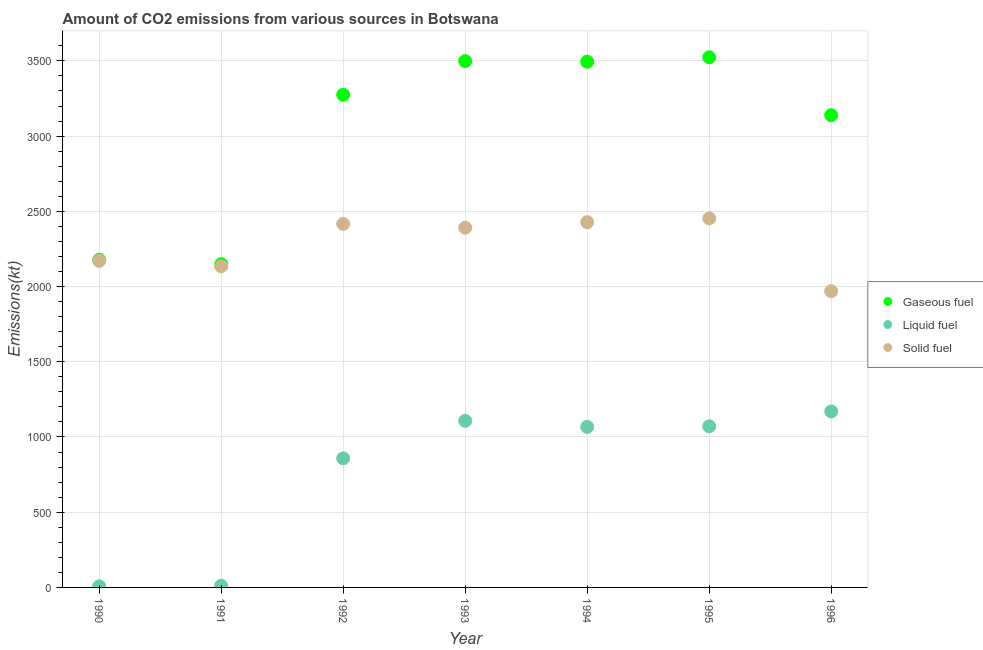What is the amount of co2 emissions from liquid fuel in 1990?
Your answer should be very brief. 7.33. Across all years, what is the maximum amount of co2 emissions from gaseous fuel?
Your response must be concise. 3523.99. Across all years, what is the minimum amount of co2 emissions from liquid fuel?
Give a very brief answer. 7.33. In which year was the amount of co2 emissions from liquid fuel minimum?
Make the answer very short. 1990. What is the total amount of co2 emissions from solid fuel in the graph?
Offer a very short reply. 1.60e+04. What is the difference between the amount of co2 emissions from gaseous fuel in 1990 and that in 1992?
Offer a very short reply. -1096.43. What is the difference between the amount of co2 emissions from gaseous fuel in 1994 and the amount of co2 emissions from liquid fuel in 1996?
Offer a very short reply. 2324.88. What is the average amount of co2 emissions from gaseous fuel per year?
Your answer should be compact. 3036.8. In the year 1991, what is the difference between the amount of co2 emissions from liquid fuel and amount of co2 emissions from solid fuel?
Provide a succinct answer. -2123.19. In how many years, is the amount of co2 emissions from liquid fuel greater than 400 kt?
Make the answer very short. 5. What is the ratio of the amount of co2 emissions from solid fuel in 1990 to that in 1992?
Your response must be concise. 0.9. Is the difference between the amount of co2 emissions from liquid fuel in 1993 and 1995 greater than the difference between the amount of co2 emissions from solid fuel in 1993 and 1995?
Your answer should be very brief. Yes. What is the difference between the highest and the second highest amount of co2 emissions from liquid fuel?
Provide a succinct answer. 62.34. What is the difference between the highest and the lowest amount of co2 emissions from liquid fuel?
Your answer should be compact. 1162.44. In how many years, is the amount of co2 emissions from gaseous fuel greater than the average amount of co2 emissions from gaseous fuel taken over all years?
Your answer should be very brief. 5. Is the sum of the amount of co2 emissions from gaseous fuel in 1991 and 1993 greater than the maximum amount of co2 emissions from liquid fuel across all years?
Offer a terse response. Yes. Does the amount of co2 emissions from gaseous fuel monotonically increase over the years?
Your answer should be compact. No. Is the amount of co2 emissions from liquid fuel strictly greater than the amount of co2 emissions from solid fuel over the years?
Keep it short and to the point. No. What is the difference between two consecutive major ticks on the Y-axis?
Your answer should be very brief. 500. Are the values on the major ticks of Y-axis written in scientific E-notation?
Your answer should be compact. No. Does the graph contain grids?
Your response must be concise. Yes. How are the legend labels stacked?
Make the answer very short. Vertical. What is the title of the graph?
Ensure brevity in your answer.  Amount of CO2 emissions from various sources in Botswana. What is the label or title of the Y-axis?
Ensure brevity in your answer.  Emissions(kt). What is the Emissions(kt) of Gaseous fuel in 1990?
Make the answer very short. 2178.2. What is the Emissions(kt) of Liquid fuel in 1990?
Give a very brief answer. 7.33. What is the Emissions(kt) of Solid fuel in 1990?
Keep it short and to the point. 2170.86. What is the Emissions(kt) in Gaseous fuel in 1991?
Provide a short and direct response. 2148.86. What is the Emissions(kt) of Liquid fuel in 1991?
Provide a short and direct response. 11. What is the Emissions(kt) of Solid fuel in 1991?
Offer a terse response. 2134.19. What is the Emissions(kt) in Gaseous fuel in 1992?
Your response must be concise. 3274.63. What is the Emissions(kt) of Liquid fuel in 1992?
Your answer should be very brief. 858.08. What is the Emissions(kt) of Solid fuel in 1992?
Provide a succinct answer. 2416.55. What is the Emissions(kt) in Gaseous fuel in 1993?
Your answer should be very brief. 3498.32. What is the Emissions(kt) of Liquid fuel in 1993?
Your response must be concise. 1107.43. What is the Emissions(kt) of Solid fuel in 1993?
Your answer should be compact. 2390.88. What is the Emissions(kt) of Gaseous fuel in 1994?
Give a very brief answer. 3494.65. What is the Emissions(kt) in Liquid fuel in 1994?
Your answer should be compact. 1067.1. What is the Emissions(kt) of Solid fuel in 1994?
Provide a short and direct response. 2427.55. What is the Emissions(kt) in Gaseous fuel in 1995?
Offer a very short reply. 3523.99. What is the Emissions(kt) of Liquid fuel in 1995?
Provide a short and direct response. 1070.76. What is the Emissions(kt) of Solid fuel in 1995?
Offer a very short reply. 2453.22. What is the Emissions(kt) in Gaseous fuel in 1996?
Provide a short and direct response. 3138.95. What is the Emissions(kt) of Liquid fuel in 1996?
Ensure brevity in your answer.  1169.77. What is the Emissions(kt) in Solid fuel in 1996?
Provide a short and direct response. 1969.18. Across all years, what is the maximum Emissions(kt) of Gaseous fuel?
Provide a succinct answer. 3523.99. Across all years, what is the maximum Emissions(kt) of Liquid fuel?
Offer a very short reply. 1169.77. Across all years, what is the maximum Emissions(kt) of Solid fuel?
Offer a terse response. 2453.22. Across all years, what is the minimum Emissions(kt) of Gaseous fuel?
Make the answer very short. 2148.86. Across all years, what is the minimum Emissions(kt) of Liquid fuel?
Provide a succinct answer. 7.33. Across all years, what is the minimum Emissions(kt) in Solid fuel?
Keep it short and to the point. 1969.18. What is the total Emissions(kt) in Gaseous fuel in the graph?
Offer a terse response. 2.13e+04. What is the total Emissions(kt) of Liquid fuel in the graph?
Offer a terse response. 5291.48. What is the total Emissions(kt) of Solid fuel in the graph?
Provide a succinct answer. 1.60e+04. What is the difference between the Emissions(kt) of Gaseous fuel in 1990 and that in 1991?
Offer a terse response. 29.34. What is the difference between the Emissions(kt) in Liquid fuel in 1990 and that in 1991?
Offer a terse response. -3.67. What is the difference between the Emissions(kt) in Solid fuel in 1990 and that in 1991?
Keep it short and to the point. 36.67. What is the difference between the Emissions(kt) of Gaseous fuel in 1990 and that in 1992?
Ensure brevity in your answer.  -1096.43. What is the difference between the Emissions(kt) of Liquid fuel in 1990 and that in 1992?
Your answer should be compact. -850.74. What is the difference between the Emissions(kt) of Solid fuel in 1990 and that in 1992?
Your response must be concise. -245.69. What is the difference between the Emissions(kt) in Gaseous fuel in 1990 and that in 1993?
Keep it short and to the point. -1320.12. What is the difference between the Emissions(kt) in Liquid fuel in 1990 and that in 1993?
Ensure brevity in your answer.  -1100.1. What is the difference between the Emissions(kt) of Solid fuel in 1990 and that in 1993?
Your answer should be compact. -220.02. What is the difference between the Emissions(kt) of Gaseous fuel in 1990 and that in 1994?
Give a very brief answer. -1316.45. What is the difference between the Emissions(kt) in Liquid fuel in 1990 and that in 1994?
Your answer should be very brief. -1059.76. What is the difference between the Emissions(kt) of Solid fuel in 1990 and that in 1994?
Offer a very short reply. -256.69. What is the difference between the Emissions(kt) in Gaseous fuel in 1990 and that in 1995?
Provide a succinct answer. -1345.79. What is the difference between the Emissions(kt) in Liquid fuel in 1990 and that in 1995?
Provide a succinct answer. -1063.43. What is the difference between the Emissions(kt) in Solid fuel in 1990 and that in 1995?
Your response must be concise. -282.36. What is the difference between the Emissions(kt) of Gaseous fuel in 1990 and that in 1996?
Provide a succinct answer. -960.75. What is the difference between the Emissions(kt) in Liquid fuel in 1990 and that in 1996?
Keep it short and to the point. -1162.44. What is the difference between the Emissions(kt) in Solid fuel in 1990 and that in 1996?
Your answer should be very brief. 201.69. What is the difference between the Emissions(kt) of Gaseous fuel in 1991 and that in 1992?
Ensure brevity in your answer.  -1125.77. What is the difference between the Emissions(kt) in Liquid fuel in 1991 and that in 1992?
Give a very brief answer. -847.08. What is the difference between the Emissions(kt) in Solid fuel in 1991 and that in 1992?
Give a very brief answer. -282.36. What is the difference between the Emissions(kt) of Gaseous fuel in 1991 and that in 1993?
Keep it short and to the point. -1349.46. What is the difference between the Emissions(kt) of Liquid fuel in 1991 and that in 1993?
Provide a succinct answer. -1096.43. What is the difference between the Emissions(kt) of Solid fuel in 1991 and that in 1993?
Your answer should be compact. -256.69. What is the difference between the Emissions(kt) of Gaseous fuel in 1991 and that in 1994?
Keep it short and to the point. -1345.79. What is the difference between the Emissions(kt) in Liquid fuel in 1991 and that in 1994?
Your response must be concise. -1056.1. What is the difference between the Emissions(kt) in Solid fuel in 1991 and that in 1994?
Your answer should be very brief. -293.36. What is the difference between the Emissions(kt) in Gaseous fuel in 1991 and that in 1995?
Make the answer very short. -1375.12. What is the difference between the Emissions(kt) of Liquid fuel in 1991 and that in 1995?
Your response must be concise. -1059.76. What is the difference between the Emissions(kt) in Solid fuel in 1991 and that in 1995?
Offer a very short reply. -319.03. What is the difference between the Emissions(kt) in Gaseous fuel in 1991 and that in 1996?
Your answer should be compact. -990.09. What is the difference between the Emissions(kt) of Liquid fuel in 1991 and that in 1996?
Give a very brief answer. -1158.77. What is the difference between the Emissions(kt) of Solid fuel in 1991 and that in 1996?
Make the answer very short. 165.01. What is the difference between the Emissions(kt) in Gaseous fuel in 1992 and that in 1993?
Offer a very short reply. -223.69. What is the difference between the Emissions(kt) of Liquid fuel in 1992 and that in 1993?
Keep it short and to the point. -249.36. What is the difference between the Emissions(kt) in Solid fuel in 1992 and that in 1993?
Offer a very short reply. 25.67. What is the difference between the Emissions(kt) in Gaseous fuel in 1992 and that in 1994?
Provide a short and direct response. -220.02. What is the difference between the Emissions(kt) in Liquid fuel in 1992 and that in 1994?
Provide a short and direct response. -209.02. What is the difference between the Emissions(kt) of Solid fuel in 1992 and that in 1994?
Offer a terse response. -11. What is the difference between the Emissions(kt) in Gaseous fuel in 1992 and that in 1995?
Your answer should be compact. -249.36. What is the difference between the Emissions(kt) of Liquid fuel in 1992 and that in 1995?
Provide a short and direct response. -212.69. What is the difference between the Emissions(kt) of Solid fuel in 1992 and that in 1995?
Offer a terse response. -36.67. What is the difference between the Emissions(kt) of Gaseous fuel in 1992 and that in 1996?
Make the answer very short. 135.68. What is the difference between the Emissions(kt) in Liquid fuel in 1992 and that in 1996?
Ensure brevity in your answer.  -311.69. What is the difference between the Emissions(kt) in Solid fuel in 1992 and that in 1996?
Provide a short and direct response. 447.37. What is the difference between the Emissions(kt) in Gaseous fuel in 1993 and that in 1994?
Your answer should be very brief. 3.67. What is the difference between the Emissions(kt) of Liquid fuel in 1993 and that in 1994?
Your response must be concise. 40.34. What is the difference between the Emissions(kt) of Solid fuel in 1993 and that in 1994?
Offer a terse response. -36.67. What is the difference between the Emissions(kt) of Gaseous fuel in 1993 and that in 1995?
Your answer should be compact. -25.67. What is the difference between the Emissions(kt) of Liquid fuel in 1993 and that in 1995?
Your answer should be very brief. 36.67. What is the difference between the Emissions(kt) in Solid fuel in 1993 and that in 1995?
Keep it short and to the point. -62.34. What is the difference between the Emissions(kt) of Gaseous fuel in 1993 and that in 1996?
Offer a terse response. 359.37. What is the difference between the Emissions(kt) in Liquid fuel in 1993 and that in 1996?
Provide a succinct answer. -62.34. What is the difference between the Emissions(kt) in Solid fuel in 1993 and that in 1996?
Give a very brief answer. 421.7. What is the difference between the Emissions(kt) in Gaseous fuel in 1994 and that in 1995?
Your response must be concise. -29.34. What is the difference between the Emissions(kt) of Liquid fuel in 1994 and that in 1995?
Your answer should be very brief. -3.67. What is the difference between the Emissions(kt) in Solid fuel in 1994 and that in 1995?
Offer a very short reply. -25.67. What is the difference between the Emissions(kt) of Gaseous fuel in 1994 and that in 1996?
Offer a very short reply. 355.7. What is the difference between the Emissions(kt) in Liquid fuel in 1994 and that in 1996?
Provide a short and direct response. -102.68. What is the difference between the Emissions(kt) in Solid fuel in 1994 and that in 1996?
Give a very brief answer. 458.38. What is the difference between the Emissions(kt) in Gaseous fuel in 1995 and that in 1996?
Your response must be concise. 385.04. What is the difference between the Emissions(kt) of Liquid fuel in 1995 and that in 1996?
Give a very brief answer. -99.01. What is the difference between the Emissions(kt) in Solid fuel in 1995 and that in 1996?
Offer a very short reply. 484.04. What is the difference between the Emissions(kt) in Gaseous fuel in 1990 and the Emissions(kt) in Liquid fuel in 1991?
Provide a succinct answer. 2167.2. What is the difference between the Emissions(kt) of Gaseous fuel in 1990 and the Emissions(kt) of Solid fuel in 1991?
Your answer should be very brief. 44. What is the difference between the Emissions(kt) of Liquid fuel in 1990 and the Emissions(kt) of Solid fuel in 1991?
Your answer should be compact. -2126.86. What is the difference between the Emissions(kt) of Gaseous fuel in 1990 and the Emissions(kt) of Liquid fuel in 1992?
Keep it short and to the point. 1320.12. What is the difference between the Emissions(kt) of Gaseous fuel in 1990 and the Emissions(kt) of Solid fuel in 1992?
Provide a short and direct response. -238.35. What is the difference between the Emissions(kt) in Liquid fuel in 1990 and the Emissions(kt) in Solid fuel in 1992?
Offer a terse response. -2409.22. What is the difference between the Emissions(kt) of Gaseous fuel in 1990 and the Emissions(kt) of Liquid fuel in 1993?
Offer a terse response. 1070.76. What is the difference between the Emissions(kt) of Gaseous fuel in 1990 and the Emissions(kt) of Solid fuel in 1993?
Make the answer very short. -212.69. What is the difference between the Emissions(kt) in Liquid fuel in 1990 and the Emissions(kt) in Solid fuel in 1993?
Make the answer very short. -2383.55. What is the difference between the Emissions(kt) of Gaseous fuel in 1990 and the Emissions(kt) of Liquid fuel in 1994?
Keep it short and to the point. 1111.1. What is the difference between the Emissions(kt) of Gaseous fuel in 1990 and the Emissions(kt) of Solid fuel in 1994?
Your response must be concise. -249.36. What is the difference between the Emissions(kt) in Liquid fuel in 1990 and the Emissions(kt) in Solid fuel in 1994?
Your answer should be very brief. -2420.22. What is the difference between the Emissions(kt) of Gaseous fuel in 1990 and the Emissions(kt) of Liquid fuel in 1995?
Give a very brief answer. 1107.43. What is the difference between the Emissions(kt) of Gaseous fuel in 1990 and the Emissions(kt) of Solid fuel in 1995?
Offer a terse response. -275.02. What is the difference between the Emissions(kt) in Liquid fuel in 1990 and the Emissions(kt) in Solid fuel in 1995?
Give a very brief answer. -2445.89. What is the difference between the Emissions(kt) in Gaseous fuel in 1990 and the Emissions(kt) in Liquid fuel in 1996?
Your answer should be compact. 1008.42. What is the difference between the Emissions(kt) in Gaseous fuel in 1990 and the Emissions(kt) in Solid fuel in 1996?
Give a very brief answer. 209.02. What is the difference between the Emissions(kt) of Liquid fuel in 1990 and the Emissions(kt) of Solid fuel in 1996?
Keep it short and to the point. -1961.85. What is the difference between the Emissions(kt) of Gaseous fuel in 1991 and the Emissions(kt) of Liquid fuel in 1992?
Provide a succinct answer. 1290.78. What is the difference between the Emissions(kt) in Gaseous fuel in 1991 and the Emissions(kt) in Solid fuel in 1992?
Your answer should be compact. -267.69. What is the difference between the Emissions(kt) of Liquid fuel in 1991 and the Emissions(kt) of Solid fuel in 1992?
Give a very brief answer. -2405.55. What is the difference between the Emissions(kt) in Gaseous fuel in 1991 and the Emissions(kt) in Liquid fuel in 1993?
Offer a terse response. 1041.43. What is the difference between the Emissions(kt) in Gaseous fuel in 1991 and the Emissions(kt) in Solid fuel in 1993?
Your response must be concise. -242.02. What is the difference between the Emissions(kt) in Liquid fuel in 1991 and the Emissions(kt) in Solid fuel in 1993?
Keep it short and to the point. -2379.88. What is the difference between the Emissions(kt) in Gaseous fuel in 1991 and the Emissions(kt) in Liquid fuel in 1994?
Your answer should be very brief. 1081.77. What is the difference between the Emissions(kt) in Gaseous fuel in 1991 and the Emissions(kt) in Solid fuel in 1994?
Ensure brevity in your answer.  -278.69. What is the difference between the Emissions(kt) in Liquid fuel in 1991 and the Emissions(kt) in Solid fuel in 1994?
Make the answer very short. -2416.55. What is the difference between the Emissions(kt) of Gaseous fuel in 1991 and the Emissions(kt) of Liquid fuel in 1995?
Your answer should be very brief. 1078.1. What is the difference between the Emissions(kt) in Gaseous fuel in 1991 and the Emissions(kt) in Solid fuel in 1995?
Offer a terse response. -304.36. What is the difference between the Emissions(kt) of Liquid fuel in 1991 and the Emissions(kt) of Solid fuel in 1995?
Offer a terse response. -2442.22. What is the difference between the Emissions(kt) of Gaseous fuel in 1991 and the Emissions(kt) of Liquid fuel in 1996?
Keep it short and to the point. 979.09. What is the difference between the Emissions(kt) of Gaseous fuel in 1991 and the Emissions(kt) of Solid fuel in 1996?
Provide a succinct answer. 179.68. What is the difference between the Emissions(kt) in Liquid fuel in 1991 and the Emissions(kt) in Solid fuel in 1996?
Your answer should be compact. -1958.18. What is the difference between the Emissions(kt) in Gaseous fuel in 1992 and the Emissions(kt) in Liquid fuel in 1993?
Provide a short and direct response. 2167.2. What is the difference between the Emissions(kt) in Gaseous fuel in 1992 and the Emissions(kt) in Solid fuel in 1993?
Your response must be concise. 883.75. What is the difference between the Emissions(kt) in Liquid fuel in 1992 and the Emissions(kt) in Solid fuel in 1993?
Ensure brevity in your answer.  -1532.81. What is the difference between the Emissions(kt) in Gaseous fuel in 1992 and the Emissions(kt) in Liquid fuel in 1994?
Provide a short and direct response. 2207.53. What is the difference between the Emissions(kt) in Gaseous fuel in 1992 and the Emissions(kt) in Solid fuel in 1994?
Ensure brevity in your answer.  847.08. What is the difference between the Emissions(kt) of Liquid fuel in 1992 and the Emissions(kt) of Solid fuel in 1994?
Provide a succinct answer. -1569.48. What is the difference between the Emissions(kt) in Gaseous fuel in 1992 and the Emissions(kt) in Liquid fuel in 1995?
Offer a very short reply. 2203.87. What is the difference between the Emissions(kt) in Gaseous fuel in 1992 and the Emissions(kt) in Solid fuel in 1995?
Provide a succinct answer. 821.41. What is the difference between the Emissions(kt) in Liquid fuel in 1992 and the Emissions(kt) in Solid fuel in 1995?
Your answer should be compact. -1595.14. What is the difference between the Emissions(kt) in Gaseous fuel in 1992 and the Emissions(kt) in Liquid fuel in 1996?
Ensure brevity in your answer.  2104.86. What is the difference between the Emissions(kt) of Gaseous fuel in 1992 and the Emissions(kt) of Solid fuel in 1996?
Your answer should be very brief. 1305.45. What is the difference between the Emissions(kt) of Liquid fuel in 1992 and the Emissions(kt) of Solid fuel in 1996?
Provide a succinct answer. -1111.1. What is the difference between the Emissions(kt) of Gaseous fuel in 1993 and the Emissions(kt) of Liquid fuel in 1994?
Provide a short and direct response. 2431.22. What is the difference between the Emissions(kt) in Gaseous fuel in 1993 and the Emissions(kt) in Solid fuel in 1994?
Give a very brief answer. 1070.76. What is the difference between the Emissions(kt) of Liquid fuel in 1993 and the Emissions(kt) of Solid fuel in 1994?
Make the answer very short. -1320.12. What is the difference between the Emissions(kt) of Gaseous fuel in 1993 and the Emissions(kt) of Liquid fuel in 1995?
Provide a succinct answer. 2427.55. What is the difference between the Emissions(kt) in Gaseous fuel in 1993 and the Emissions(kt) in Solid fuel in 1995?
Keep it short and to the point. 1045.1. What is the difference between the Emissions(kt) in Liquid fuel in 1993 and the Emissions(kt) in Solid fuel in 1995?
Make the answer very short. -1345.79. What is the difference between the Emissions(kt) in Gaseous fuel in 1993 and the Emissions(kt) in Liquid fuel in 1996?
Ensure brevity in your answer.  2328.55. What is the difference between the Emissions(kt) of Gaseous fuel in 1993 and the Emissions(kt) of Solid fuel in 1996?
Offer a terse response. 1529.14. What is the difference between the Emissions(kt) in Liquid fuel in 1993 and the Emissions(kt) in Solid fuel in 1996?
Offer a terse response. -861.75. What is the difference between the Emissions(kt) in Gaseous fuel in 1994 and the Emissions(kt) in Liquid fuel in 1995?
Make the answer very short. 2423.89. What is the difference between the Emissions(kt) of Gaseous fuel in 1994 and the Emissions(kt) of Solid fuel in 1995?
Your response must be concise. 1041.43. What is the difference between the Emissions(kt) in Liquid fuel in 1994 and the Emissions(kt) in Solid fuel in 1995?
Give a very brief answer. -1386.13. What is the difference between the Emissions(kt) in Gaseous fuel in 1994 and the Emissions(kt) in Liquid fuel in 1996?
Provide a short and direct response. 2324.88. What is the difference between the Emissions(kt) in Gaseous fuel in 1994 and the Emissions(kt) in Solid fuel in 1996?
Keep it short and to the point. 1525.47. What is the difference between the Emissions(kt) of Liquid fuel in 1994 and the Emissions(kt) of Solid fuel in 1996?
Offer a very short reply. -902.08. What is the difference between the Emissions(kt) of Gaseous fuel in 1995 and the Emissions(kt) of Liquid fuel in 1996?
Provide a short and direct response. 2354.21. What is the difference between the Emissions(kt) in Gaseous fuel in 1995 and the Emissions(kt) in Solid fuel in 1996?
Keep it short and to the point. 1554.81. What is the difference between the Emissions(kt) in Liquid fuel in 1995 and the Emissions(kt) in Solid fuel in 1996?
Your response must be concise. -898.41. What is the average Emissions(kt) in Gaseous fuel per year?
Offer a terse response. 3036.8. What is the average Emissions(kt) of Liquid fuel per year?
Give a very brief answer. 755.93. What is the average Emissions(kt) in Solid fuel per year?
Your response must be concise. 2280.35. In the year 1990, what is the difference between the Emissions(kt) of Gaseous fuel and Emissions(kt) of Liquid fuel?
Your answer should be very brief. 2170.86. In the year 1990, what is the difference between the Emissions(kt) of Gaseous fuel and Emissions(kt) of Solid fuel?
Offer a terse response. 7.33. In the year 1990, what is the difference between the Emissions(kt) of Liquid fuel and Emissions(kt) of Solid fuel?
Your answer should be very brief. -2163.53. In the year 1991, what is the difference between the Emissions(kt) of Gaseous fuel and Emissions(kt) of Liquid fuel?
Offer a very short reply. 2137.86. In the year 1991, what is the difference between the Emissions(kt) of Gaseous fuel and Emissions(kt) of Solid fuel?
Keep it short and to the point. 14.67. In the year 1991, what is the difference between the Emissions(kt) in Liquid fuel and Emissions(kt) in Solid fuel?
Provide a short and direct response. -2123.19. In the year 1992, what is the difference between the Emissions(kt) in Gaseous fuel and Emissions(kt) in Liquid fuel?
Give a very brief answer. 2416.55. In the year 1992, what is the difference between the Emissions(kt) of Gaseous fuel and Emissions(kt) of Solid fuel?
Provide a succinct answer. 858.08. In the year 1992, what is the difference between the Emissions(kt) of Liquid fuel and Emissions(kt) of Solid fuel?
Offer a very short reply. -1558.47. In the year 1993, what is the difference between the Emissions(kt) of Gaseous fuel and Emissions(kt) of Liquid fuel?
Provide a succinct answer. 2390.88. In the year 1993, what is the difference between the Emissions(kt) in Gaseous fuel and Emissions(kt) in Solid fuel?
Provide a succinct answer. 1107.43. In the year 1993, what is the difference between the Emissions(kt) in Liquid fuel and Emissions(kt) in Solid fuel?
Offer a terse response. -1283.45. In the year 1994, what is the difference between the Emissions(kt) of Gaseous fuel and Emissions(kt) of Liquid fuel?
Your answer should be very brief. 2427.55. In the year 1994, what is the difference between the Emissions(kt) of Gaseous fuel and Emissions(kt) of Solid fuel?
Your answer should be compact. 1067.1. In the year 1994, what is the difference between the Emissions(kt) in Liquid fuel and Emissions(kt) in Solid fuel?
Make the answer very short. -1360.46. In the year 1995, what is the difference between the Emissions(kt) in Gaseous fuel and Emissions(kt) in Liquid fuel?
Your answer should be compact. 2453.22. In the year 1995, what is the difference between the Emissions(kt) in Gaseous fuel and Emissions(kt) in Solid fuel?
Offer a terse response. 1070.76. In the year 1995, what is the difference between the Emissions(kt) of Liquid fuel and Emissions(kt) of Solid fuel?
Provide a short and direct response. -1382.46. In the year 1996, what is the difference between the Emissions(kt) in Gaseous fuel and Emissions(kt) in Liquid fuel?
Offer a terse response. 1969.18. In the year 1996, what is the difference between the Emissions(kt) of Gaseous fuel and Emissions(kt) of Solid fuel?
Your response must be concise. 1169.77. In the year 1996, what is the difference between the Emissions(kt) of Liquid fuel and Emissions(kt) of Solid fuel?
Give a very brief answer. -799.41. What is the ratio of the Emissions(kt) of Gaseous fuel in 1990 to that in 1991?
Ensure brevity in your answer.  1.01. What is the ratio of the Emissions(kt) of Liquid fuel in 1990 to that in 1991?
Your response must be concise. 0.67. What is the ratio of the Emissions(kt) in Solid fuel in 1990 to that in 1991?
Provide a short and direct response. 1.02. What is the ratio of the Emissions(kt) of Gaseous fuel in 1990 to that in 1992?
Your answer should be very brief. 0.67. What is the ratio of the Emissions(kt) in Liquid fuel in 1990 to that in 1992?
Provide a short and direct response. 0.01. What is the ratio of the Emissions(kt) in Solid fuel in 1990 to that in 1992?
Your answer should be compact. 0.9. What is the ratio of the Emissions(kt) of Gaseous fuel in 1990 to that in 1993?
Offer a terse response. 0.62. What is the ratio of the Emissions(kt) in Liquid fuel in 1990 to that in 1993?
Ensure brevity in your answer.  0.01. What is the ratio of the Emissions(kt) of Solid fuel in 1990 to that in 1993?
Provide a succinct answer. 0.91. What is the ratio of the Emissions(kt) of Gaseous fuel in 1990 to that in 1994?
Your response must be concise. 0.62. What is the ratio of the Emissions(kt) in Liquid fuel in 1990 to that in 1994?
Provide a short and direct response. 0.01. What is the ratio of the Emissions(kt) in Solid fuel in 1990 to that in 1994?
Your answer should be very brief. 0.89. What is the ratio of the Emissions(kt) in Gaseous fuel in 1990 to that in 1995?
Make the answer very short. 0.62. What is the ratio of the Emissions(kt) in Liquid fuel in 1990 to that in 1995?
Keep it short and to the point. 0.01. What is the ratio of the Emissions(kt) of Solid fuel in 1990 to that in 1995?
Offer a terse response. 0.88. What is the ratio of the Emissions(kt) of Gaseous fuel in 1990 to that in 1996?
Give a very brief answer. 0.69. What is the ratio of the Emissions(kt) in Liquid fuel in 1990 to that in 1996?
Your answer should be compact. 0.01. What is the ratio of the Emissions(kt) in Solid fuel in 1990 to that in 1996?
Give a very brief answer. 1.1. What is the ratio of the Emissions(kt) in Gaseous fuel in 1991 to that in 1992?
Ensure brevity in your answer.  0.66. What is the ratio of the Emissions(kt) in Liquid fuel in 1991 to that in 1992?
Ensure brevity in your answer.  0.01. What is the ratio of the Emissions(kt) of Solid fuel in 1991 to that in 1992?
Give a very brief answer. 0.88. What is the ratio of the Emissions(kt) of Gaseous fuel in 1991 to that in 1993?
Offer a terse response. 0.61. What is the ratio of the Emissions(kt) in Liquid fuel in 1991 to that in 1993?
Offer a very short reply. 0.01. What is the ratio of the Emissions(kt) in Solid fuel in 1991 to that in 1993?
Make the answer very short. 0.89. What is the ratio of the Emissions(kt) of Gaseous fuel in 1991 to that in 1994?
Give a very brief answer. 0.61. What is the ratio of the Emissions(kt) of Liquid fuel in 1991 to that in 1994?
Offer a very short reply. 0.01. What is the ratio of the Emissions(kt) in Solid fuel in 1991 to that in 1994?
Provide a succinct answer. 0.88. What is the ratio of the Emissions(kt) of Gaseous fuel in 1991 to that in 1995?
Your response must be concise. 0.61. What is the ratio of the Emissions(kt) in Liquid fuel in 1991 to that in 1995?
Keep it short and to the point. 0.01. What is the ratio of the Emissions(kt) in Solid fuel in 1991 to that in 1995?
Give a very brief answer. 0.87. What is the ratio of the Emissions(kt) of Gaseous fuel in 1991 to that in 1996?
Ensure brevity in your answer.  0.68. What is the ratio of the Emissions(kt) in Liquid fuel in 1991 to that in 1996?
Offer a terse response. 0.01. What is the ratio of the Emissions(kt) in Solid fuel in 1991 to that in 1996?
Offer a very short reply. 1.08. What is the ratio of the Emissions(kt) of Gaseous fuel in 1992 to that in 1993?
Your answer should be compact. 0.94. What is the ratio of the Emissions(kt) in Liquid fuel in 1992 to that in 1993?
Provide a short and direct response. 0.77. What is the ratio of the Emissions(kt) of Solid fuel in 1992 to that in 1993?
Make the answer very short. 1.01. What is the ratio of the Emissions(kt) of Gaseous fuel in 1992 to that in 1994?
Your answer should be very brief. 0.94. What is the ratio of the Emissions(kt) in Liquid fuel in 1992 to that in 1994?
Give a very brief answer. 0.8. What is the ratio of the Emissions(kt) of Solid fuel in 1992 to that in 1994?
Offer a terse response. 1. What is the ratio of the Emissions(kt) of Gaseous fuel in 1992 to that in 1995?
Offer a terse response. 0.93. What is the ratio of the Emissions(kt) of Liquid fuel in 1992 to that in 1995?
Offer a terse response. 0.8. What is the ratio of the Emissions(kt) of Solid fuel in 1992 to that in 1995?
Give a very brief answer. 0.99. What is the ratio of the Emissions(kt) in Gaseous fuel in 1992 to that in 1996?
Your answer should be compact. 1.04. What is the ratio of the Emissions(kt) in Liquid fuel in 1992 to that in 1996?
Make the answer very short. 0.73. What is the ratio of the Emissions(kt) in Solid fuel in 1992 to that in 1996?
Your answer should be compact. 1.23. What is the ratio of the Emissions(kt) in Liquid fuel in 1993 to that in 1994?
Provide a short and direct response. 1.04. What is the ratio of the Emissions(kt) of Solid fuel in 1993 to that in 1994?
Provide a succinct answer. 0.98. What is the ratio of the Emissions(kt) of Liquid fuel in 1993 to that in 1995?
Offer a very short reply. 1.03. What is the ratio of the Emissions(kt) in Solid fuel in 1993 to that in 1995?
Keep it short and to the point. 0.97. What is the ratio of the Emissions(kt) of Gaseous fuel in 1993 to that in 1996?
Offer a very short reply. 1.11. What is the ratio of the Emissions(kt) of Liquid fuel in 1993 to that in 1996?
Offer a terse response. 0.95. What is the ratio of the Emissions(kt) of Solid fuel in 1993 to that in 1996?
Offer a terse response. 1.21. What is the ratio of the Emissions(kt) of Liquid fuel in 1994 to that in 1995?
Your answer should be compact. 1. What is the ratio of the Emissions(kt) in Gaseous fuel in 1994 to that in 1996?
Give a very brief answer. 1.11. What is the ratio of the Emissions(kt) of Liquid fuel in 1994 to that in 1996?
Your answer should be compact. 0.91. What is the ratio of the Emissions(kt) in Solid fuel in 1994 to that in 1996?
Give a very brief answer. 1.23. What is the ratio of the Emissions(kt) of Gaseous fuel in 1995 to that in 1996?
Give a very brief answer. 1.12. What is the ratio of the Emissions(kt) of Liquid fuel in 1995 to that in 1996?
Provide a succinct answer. 0.92. What is the ratio of the Emissions(kt) of Solid fuel in 1995 to that in 1996?
Give a very brief answer. 1.25. What is the difference between the highest and the second highest Emissions(kt) in Gaseous fuel?
Your response must be concise. 25.67. What is the difference between the highest and the second highest Emissions(kt) in Liquid fuel?
Provide a succinct answer. 62.34. What is the difference between the highest and the second highest Emissions(kt) of Solid fuel?
Your answer should be very brief. 25.67. What is the difference between the highest and the lowest Emissions(kt) of Gaseous fuel?
Keep it short and to the point. 1375.12. What is the difference between the highest and the lowest Emissions(kt) in Liquid fuel?
Your answer should be compact. 1162.44. What is the difference between the highest and the lowest Emissions(kt) of Solid fuel?
Ensure brevity in your answer.  484.04. 